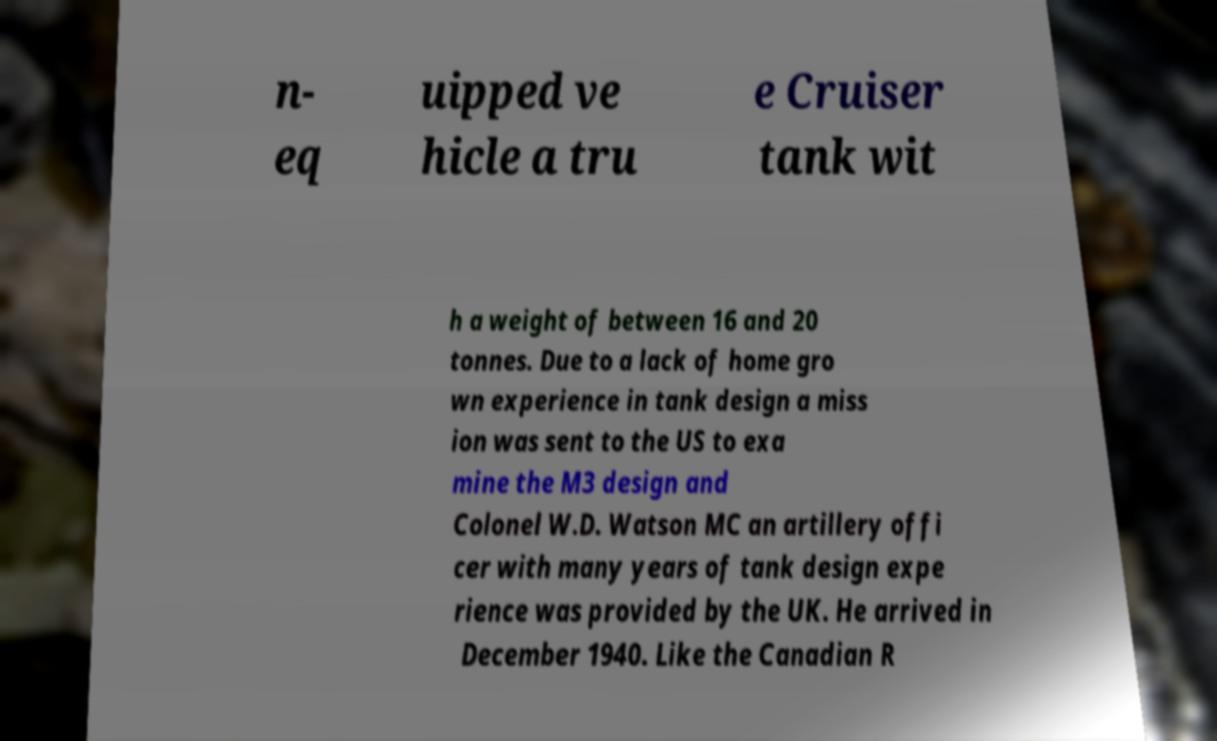I need the written content from this picture converted into text. Can you do that? n- eq uipped ve hicle a tru e Cruiser tank wit h a weight of between 16 and 20 tonnes. Due to a lack of home gro wn experience in tank design a miss ion was sent to the US to exa mine the M3 design and Colonel W.D. Watson MC an artillery offi cer with many years of tank design expe rience was provided by the UK. He arrived in December 1940. Like the Canadian R 